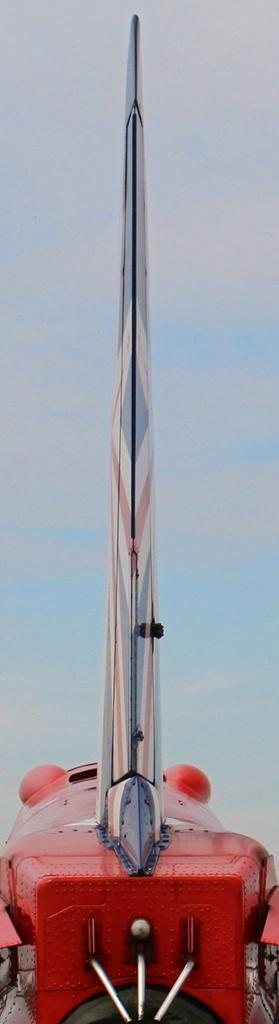What color is the prominent object in the image? There is a red object in the image. What colors make up the background of the image? The background of the image is white and blue. What type of objects are on the red object? There are silver objects on the red object. How many cats are sitting on the side of the red object in the image? There are no cats present in the image. 